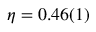<formula> <loc_0><loc_0><loc_500><loc_500>\eta = 0 . 4 6 ( 1 )</formula> 